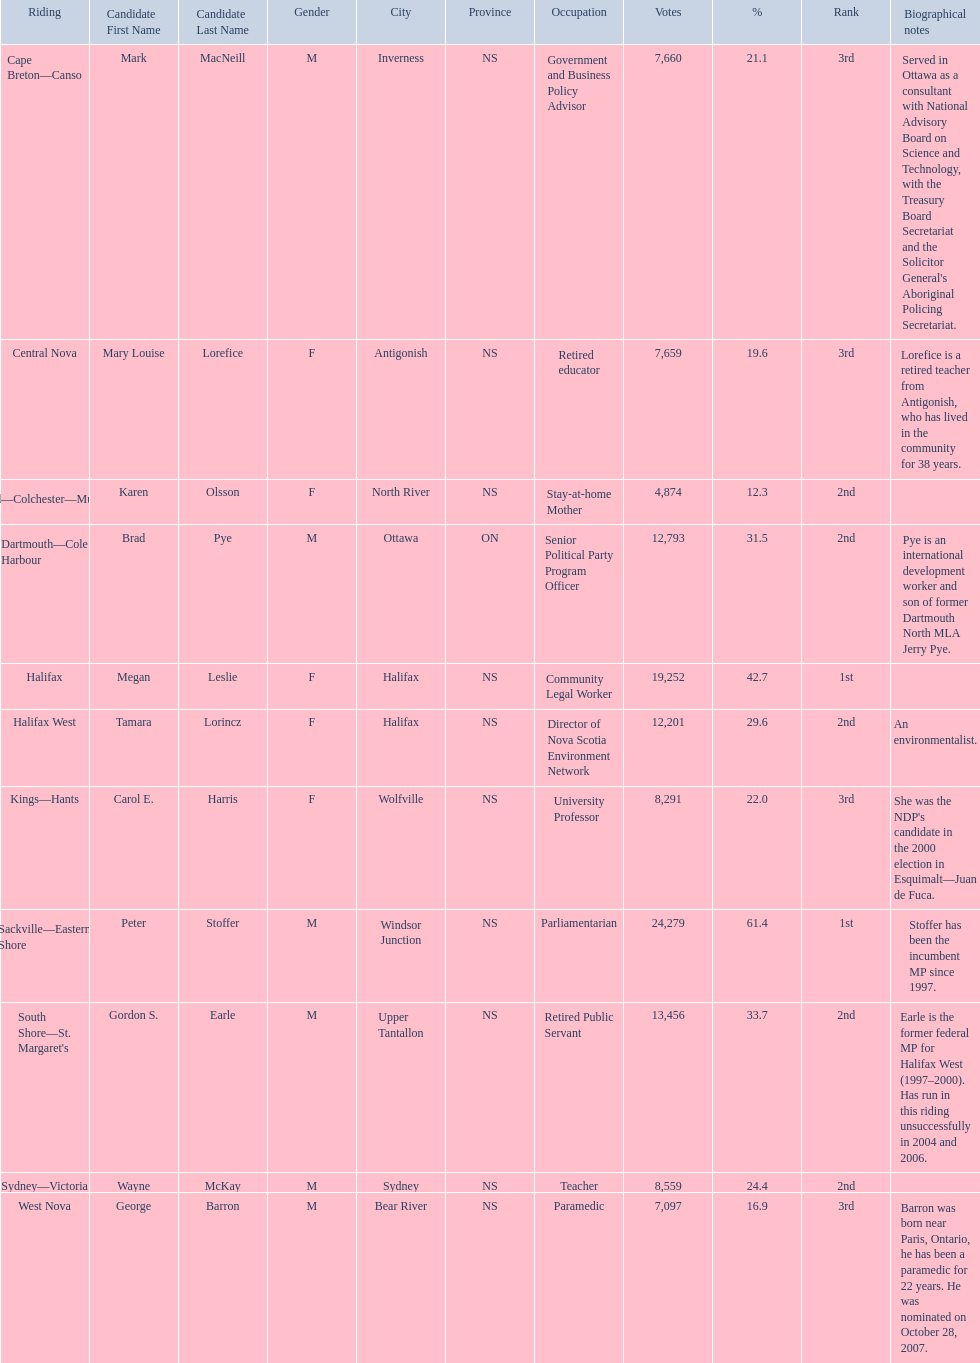Who got a larger number of votes, macneill or olsson? Mark MacNeill. 